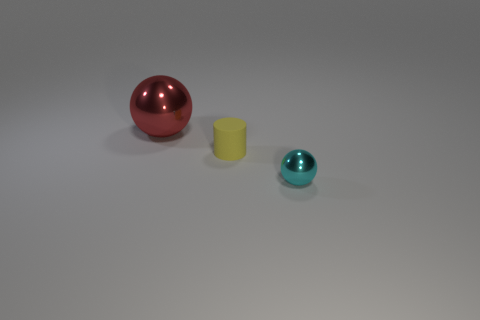What could be the context or setting of this image? The image appears to be set in a controlled environment, potentially for the purpose of illustrating size comparison or for a photographic composition exercise. The uniform lighting and plain background suggest a studio setting where the focus is on the objects themselves, free from external distractions. 